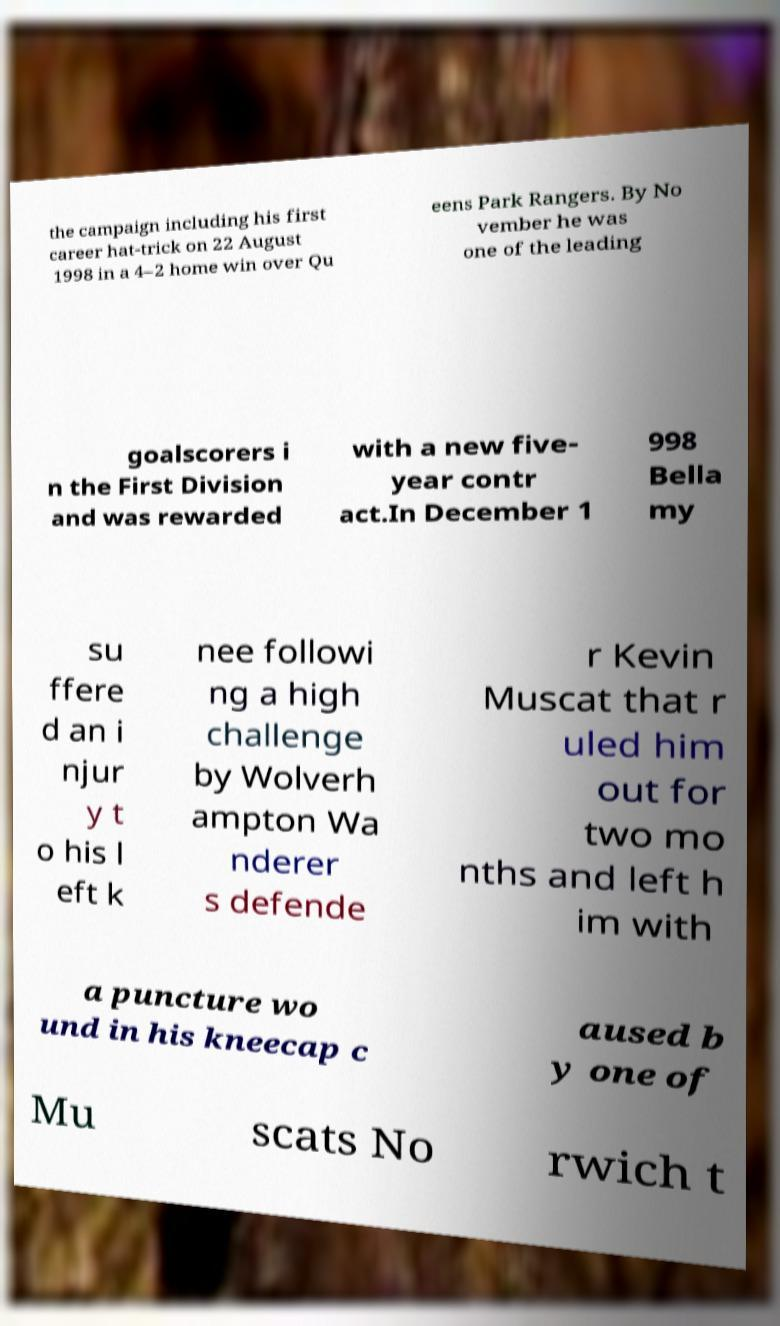Can you read and provide the text displayed in the image?This photo seems to have some interesting text. Can you extract and type it out for me? the campaign including his first career hat-trick on 22 August 1998 in a 4–2 home win over Qu eens Park Rangers. By No vember he was one of the leading goalscorers i n the First Division and was rewarded with a new five- year contr act.In December 1 998 Bella my su ffere d an i njur y t o his l eft k nee followi ng a high challenge by Wolverh ampton Wa nderer s defende r Kevin Muscat that r uled him out for two mo nths and left h im with a puncture wo und in his kneecap c aused b y one of Mu scats No rwich t 